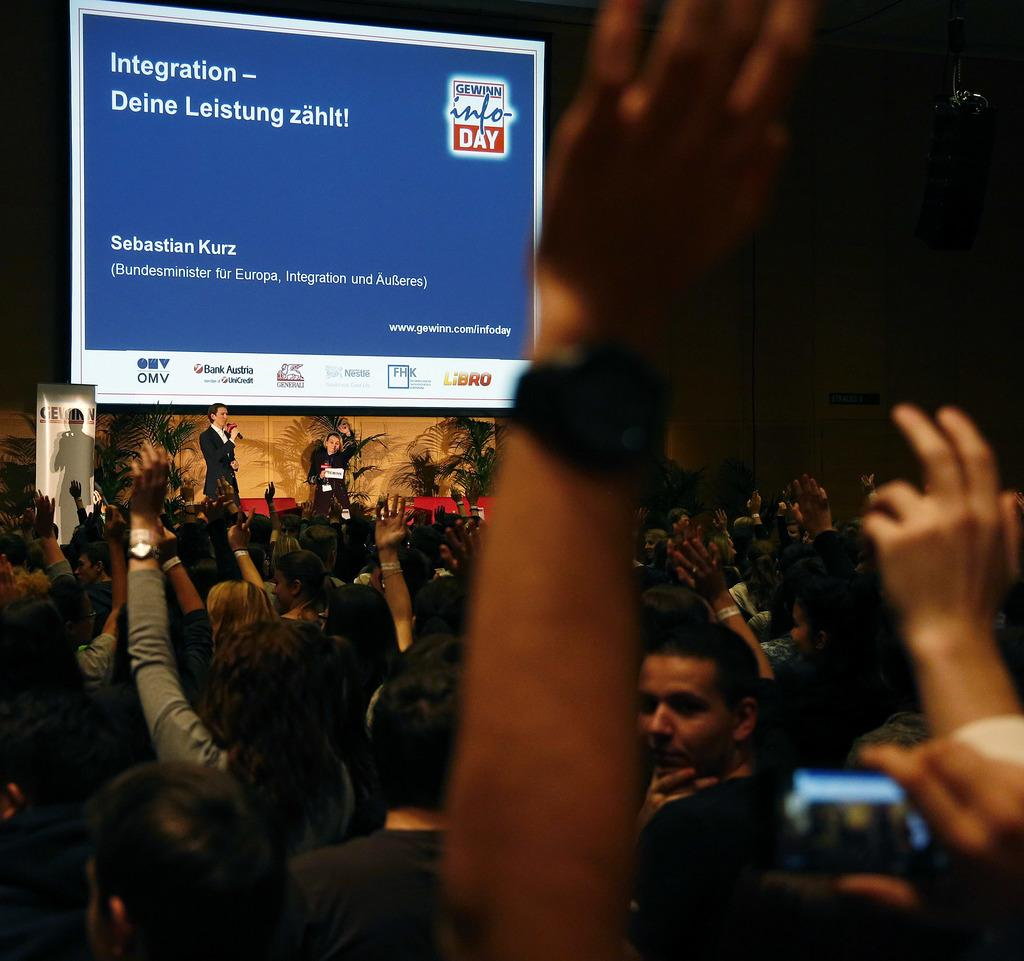What is the main subject of the image? The main subject of the image is a crowd. Can you describe the positions of two specific persons in the image? Two persons are standing in the back of the crowd. What structure can be seen in the image? There is a stand in the image. What is present in the background of the image? There is a screen in the background of the image. What can be seen on the screen? Something is written on the screen. How many tins of paint are visible in the image? There are no tins of paint present in the image. Can you describe the snake that is slithering through the crowd? There is no snake present in the image; it only features a crowd, a stand, a screen, and two persons standing in the back. 